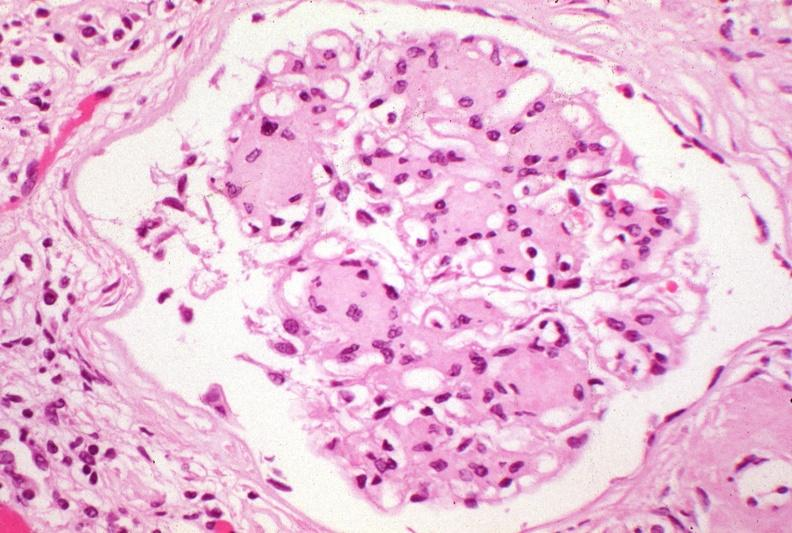does this image show kidney, kw kimmelstiel-wilson?
Answer the question using a single word or phrase. Yes 